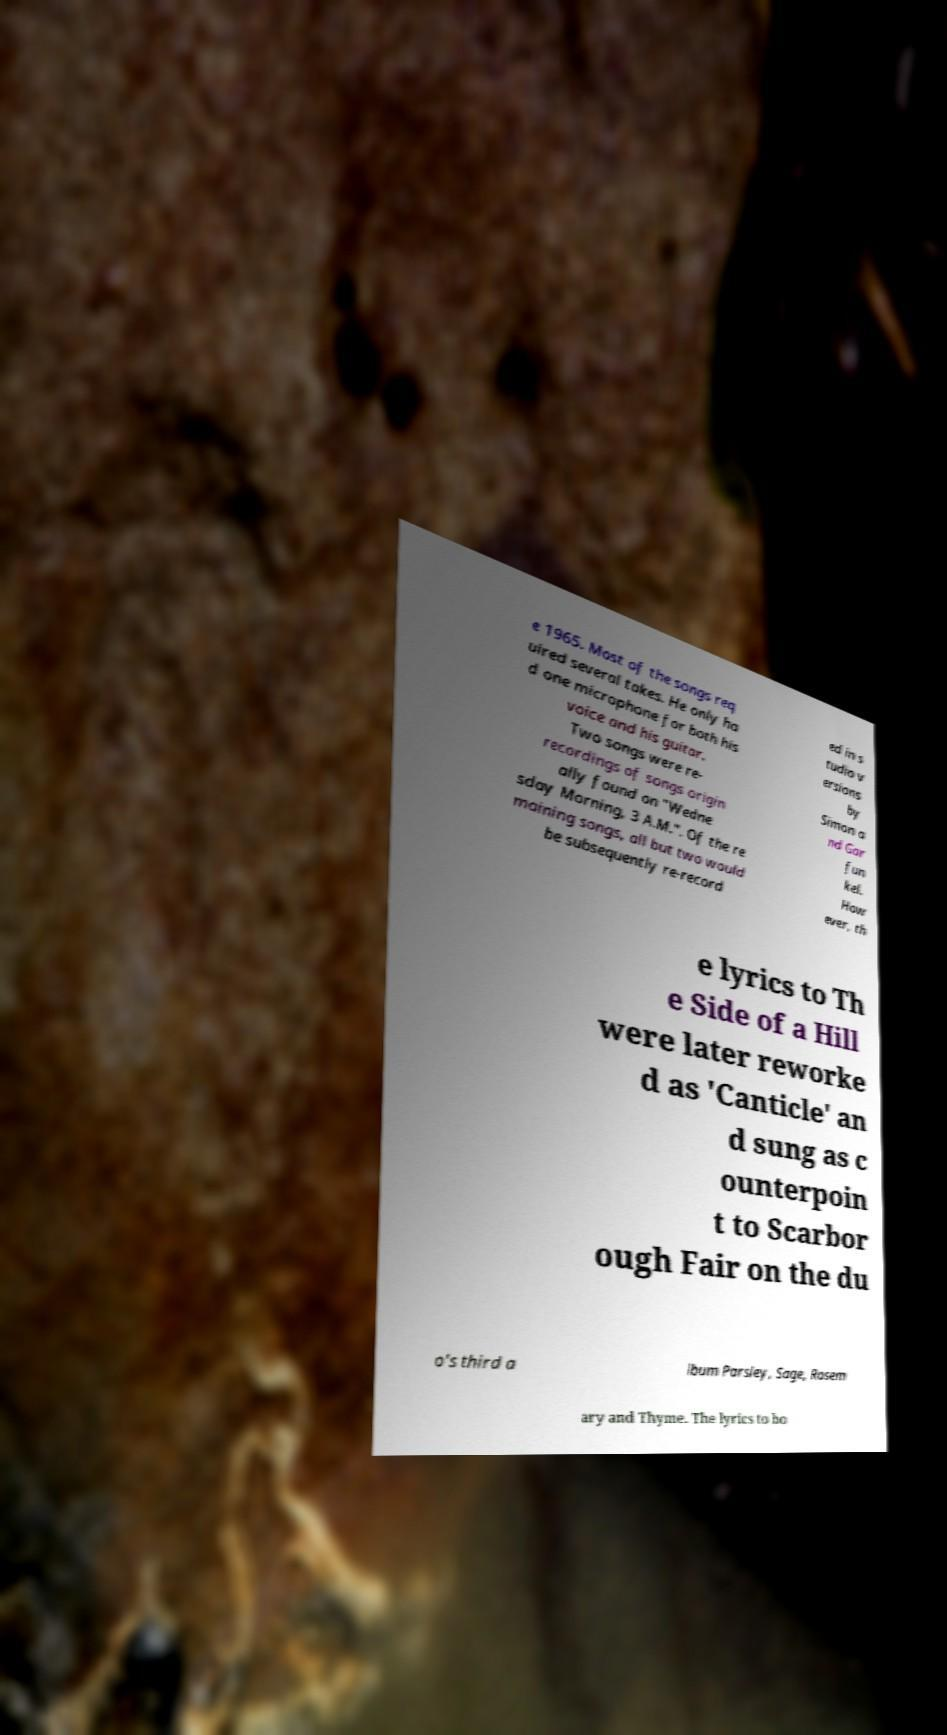For documentation purposes, I need the text within this image transcribed. Could you provide that? e 1965. Most of the songs req uired several takes. He only ha d one microphone for both his voice and his guitar. Two songs were re- recordings of songs origin ally found on "Wedne sday Morning, 3 A.M.". Of the re maining songs, all but two would be subsequently re-record ed in s tudio v ersions by Simon a nd Gar fun kel. How ever, th e lyrics to Th e Side of a Hill were later reworke d as 'Canticle' an d sung as c ounterpoin t to Scarbor ough Fair on the du o's third a lbum Parsley, Sage, Rosem ary and Thyme. The lyrics to bo 